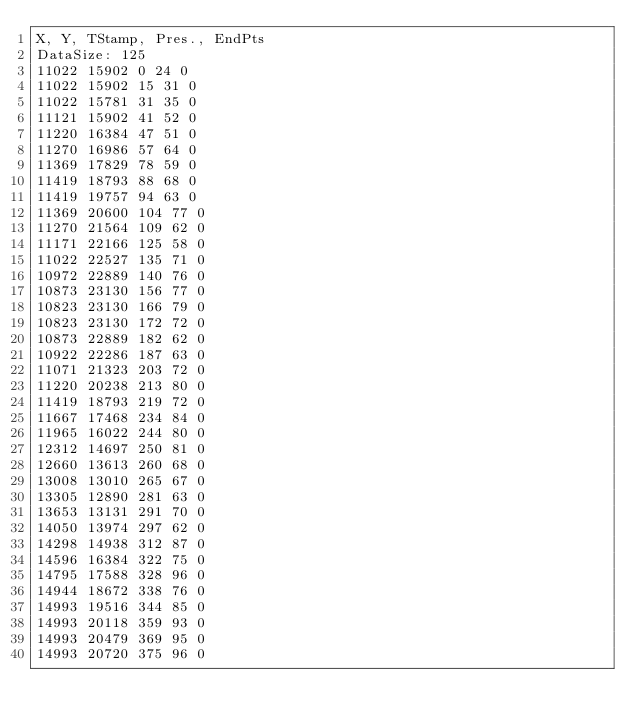Convert code to text. <code><loc_0><loc_0><loc_500><loc_500><_SML_>X, Y, TStamp, Pres., EndPts
DataSize: 125
11022 15902 0 24 0
11022 15902 15 31 0
11022 15781 31 35 0
11121 15902 41 52 0
11220 16384 47 51 0
11270 16986 57 64 0
11369 17829 78 59 0
11419 18793 88 68 0
11419 19757 94 63 0
11369 20600 104 77 0
11270 21564 109 62 0
11171 22166 125 58 0
11022 22527 135 71 0
10972 22889 140 76 0
10873 23130 156 77 0
10823 23130 166 79 0
10823 23130 172 72 0
10873 22889 182 62 0
10922 22286 187 63 0
11071 21323 203 72 0
11220 20238 213 80 0
11419 18793 219 72 0
11667 17468 234 84 0
11965 16022 244 80 0
12312 14697 250 81 0
12660 13613 260 68 0
13008 13010 265 67 0
13305 12890 281 63 0
13653 13131 291 70 0
14050 13974 297 62 0
14298 14938 312 87 0
14596 16384 322 75 0
14795 17588 328 96 0
14944 18672 338 76 0
14993 19516 344 85 0
14993 20118 359 93 0
14993 20479 369 95 0
14993 20720 375 96 0</code> 